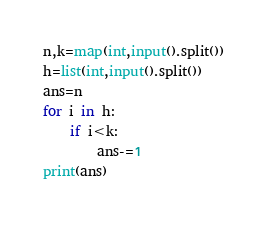Convert code to text. <code><loc_0><loc_0><loc_500><loc_500><_Python_>n,k=map(int,input().split())
h=list(int,input().split())
ans=n
for i in h:
    if i<k:
        ans-=1
print(ans)
</code> 